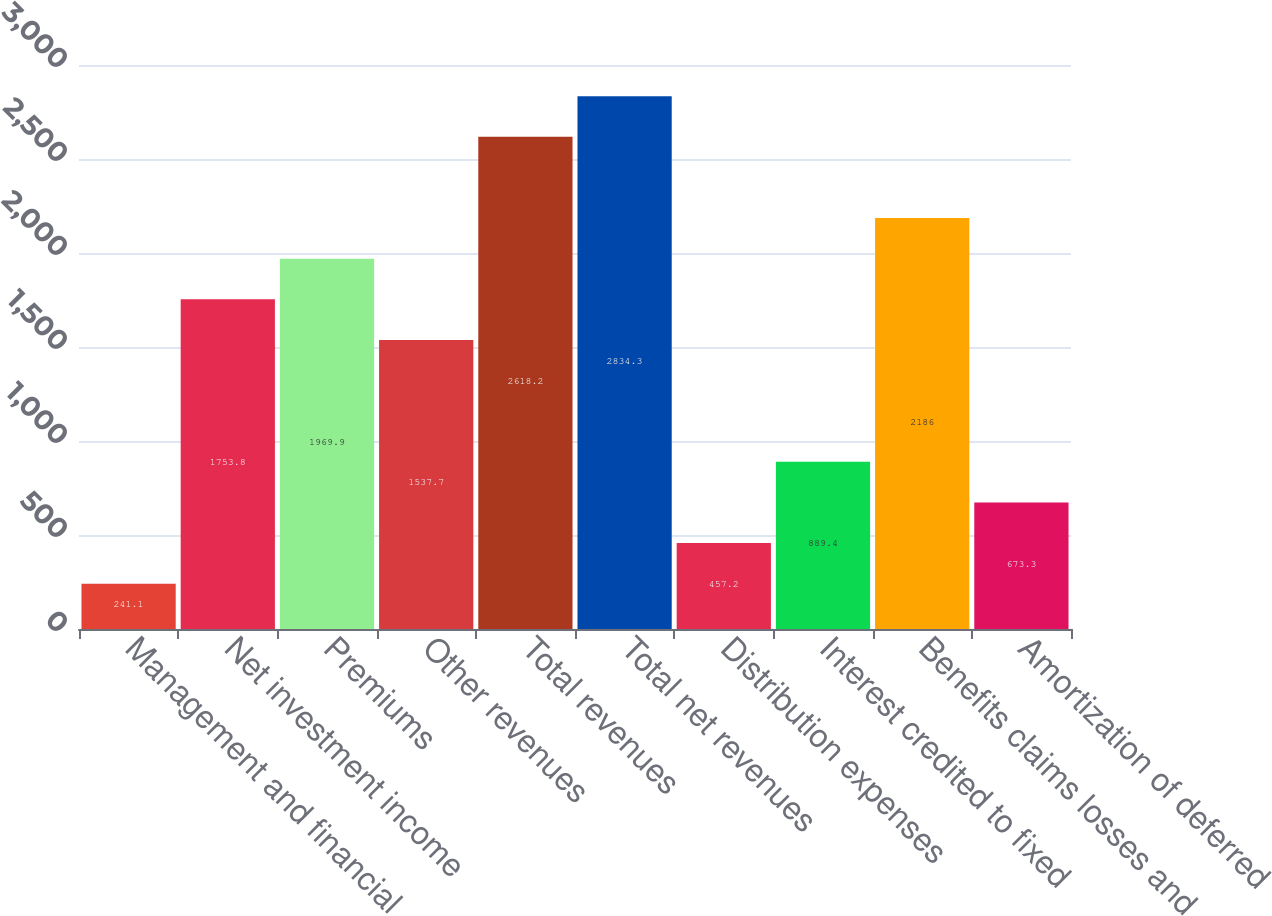<chart> <loc_0><loc_0><loc_500><loc_500><bar_chart><fcel>Management and financial<fcel>Net investment income<fcel>Premiums<fcel>Other revenues<fcel>Total revenues<fcel>Total net revenues<fcel>Distribution expenses<fcel>Interest credited to fixed<fcel>Benefits claims losses and<fcel>Amortization of deferred<nl><fcel>241.1<fcel>1753.8<fcel>1969.9<fcel>1537.7<fcel>2618.2<fcel>2834.3<fcel>457.2<fcel>889.4<fcel>2186<fcel>673.3<nl></chart> 